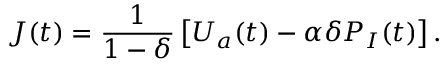Convert formula to latex. <formula><loc_0><loc_0><loc_500><loc_500>J ( t ) = \frac { 1 } { 1 - \delta } \left [ U _ { a } ( t ) - \alpha \delta P _ { I } ( t ) \right ] .</formula> 